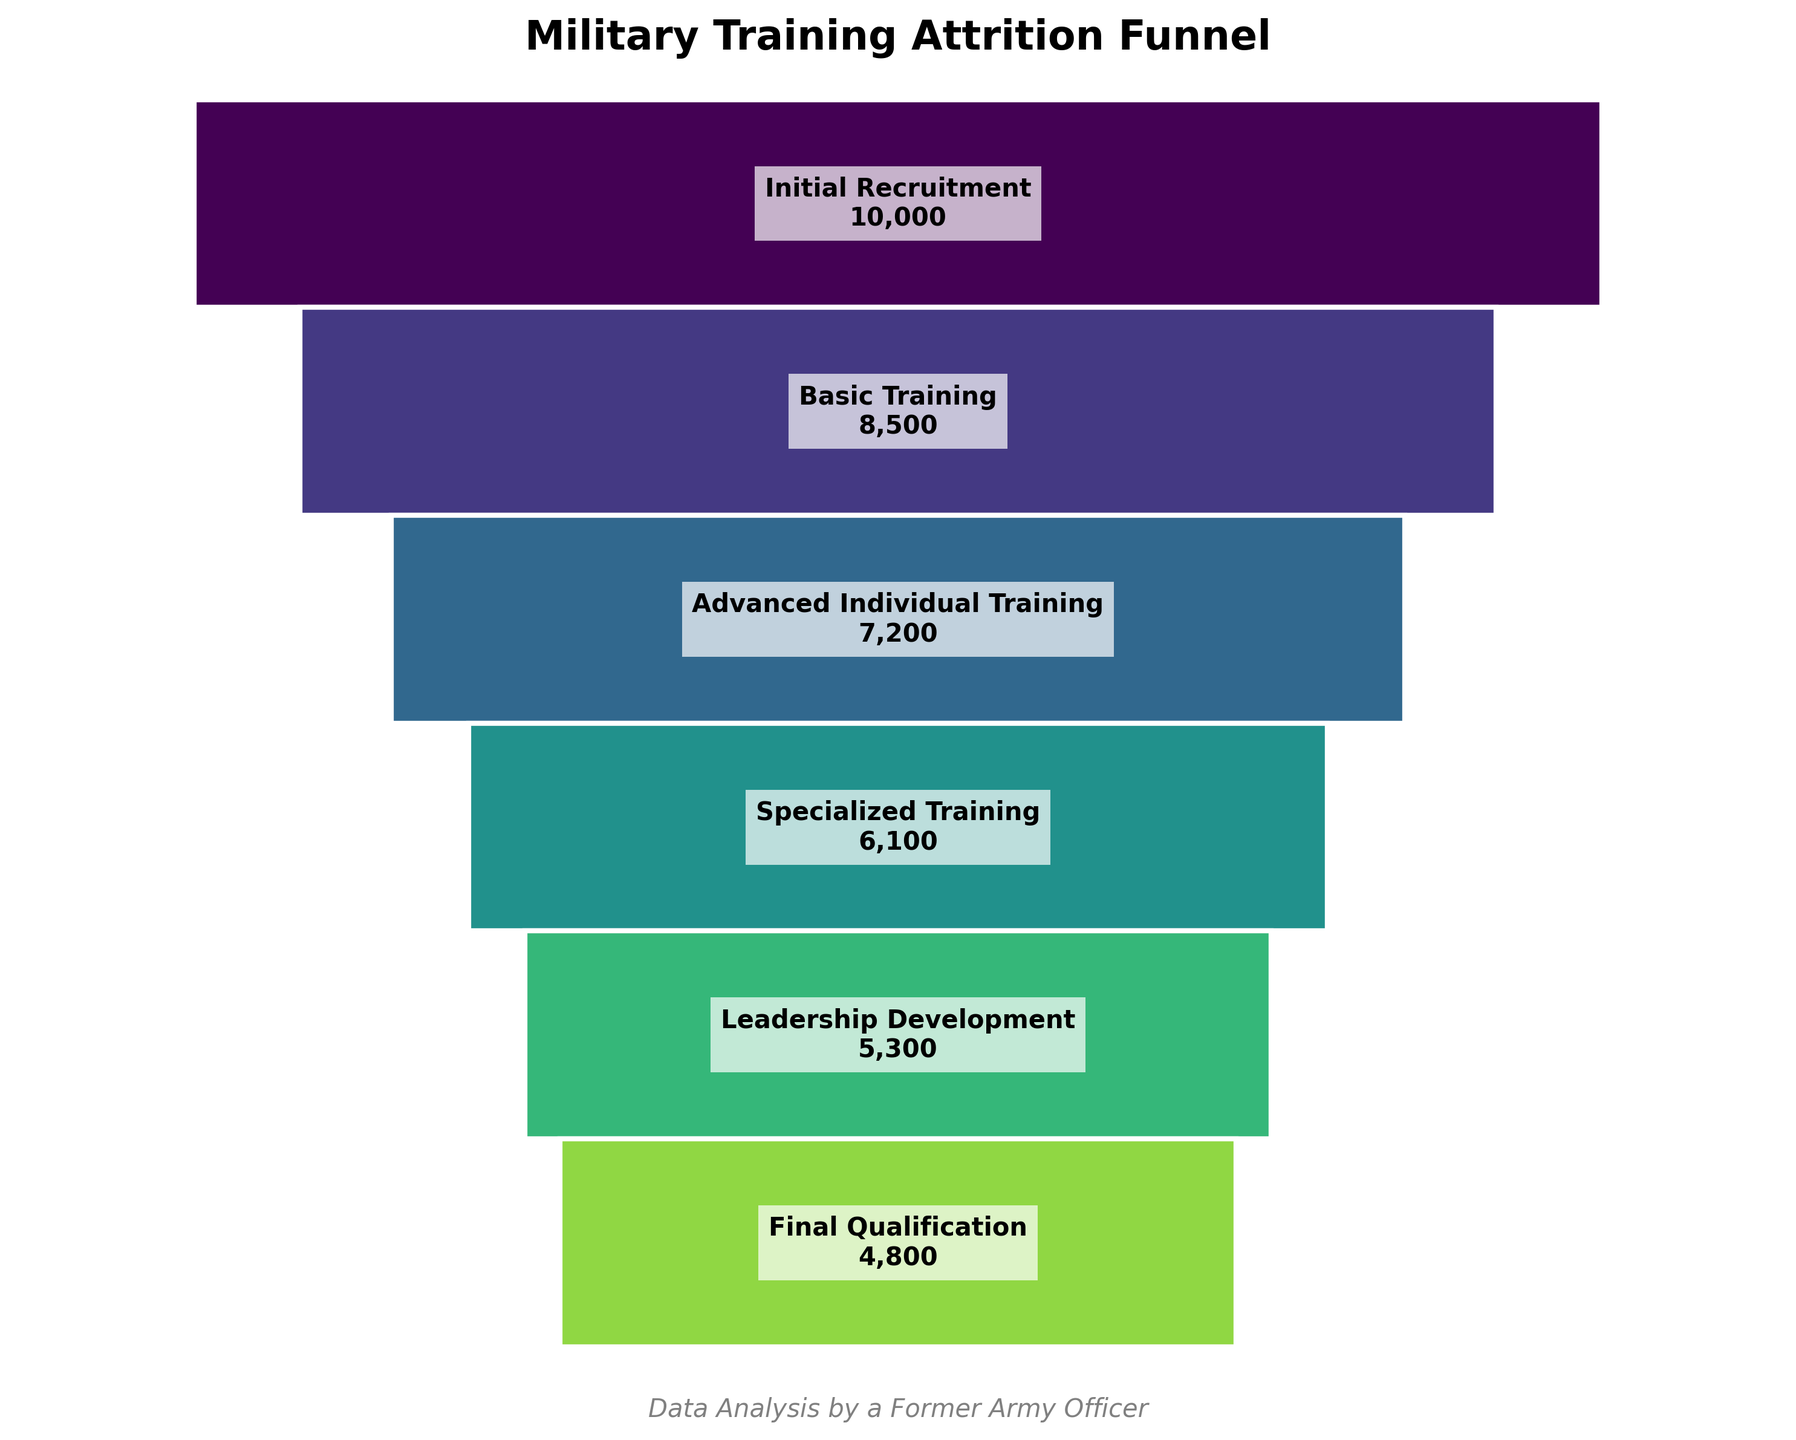what is the title of the figure? The title is usually placed prominently at the top of the figure. Here, it reads "Military Training Attrition Funnel".
Answer: Military Training Attrition Funnel How many stages or phases are represented in the figure? By observing the figure, we see distinct labels for each phase of the training process. Counting them gives us the total number of phases.
Answer: 6 What phase has the highest number of candidates? The topmost phase typically has the highest number of candidates. In this figure, the "Initial Recruitment" phase is at the top with 10,000 candidates.
Answer: Initial Recruitment Compare the number of candidates in Basic Training and Final Qualification. Which phase has more candidates? "Basic Training" is higher up in the funnel compared to "Final Qualification". Checking their labels, Basic Training has 8,500 candidates and Final Qualification has 4,800 candidates.
Answer: Basic Training What is the difference in the number of candidates between the Advanced Individual Training and Specialized Training phases? From the labels, Advanced Individual Training has 7,200 candidates while Specialized Training has 6,100 candidates. Subtracting these gives us the difference.
Answer: 1,100 What is the percentage drop in candidates from Initial Recruitment to Basic Training? The difference in candidates between these phases is (10,000 - 8,500 = 1,500). The percentage drop is (1,500 / 10,000) * 100.
Answer: 15% Calculate the total number of candidates that completed Advanced Individual Training and Leadership Development phases combined. By adding the candidate numbers from these phases (7,200 for Advanced Individual Training and 5,300 for Leadership Development), we get the total.
Answer: 12,500 Which phase has seen the least reduction in candidates compared to the previous phase? Examine the reductions between each successive pair of phases. The smallest reduction is between Leadership Development and Final Qualification, from 5,300 to 4,800 (500 candidates).
Answer: Leadership Development to Final Qualification What's the ratio of candidates in Specialized Training to Leadership Development? From the figure, there are 6,100 candidates in Specialized Training and 5,300 in Leadership Development. The ratio can be expressed as 6,100:5,300.
Answer: 6,100:5,300 